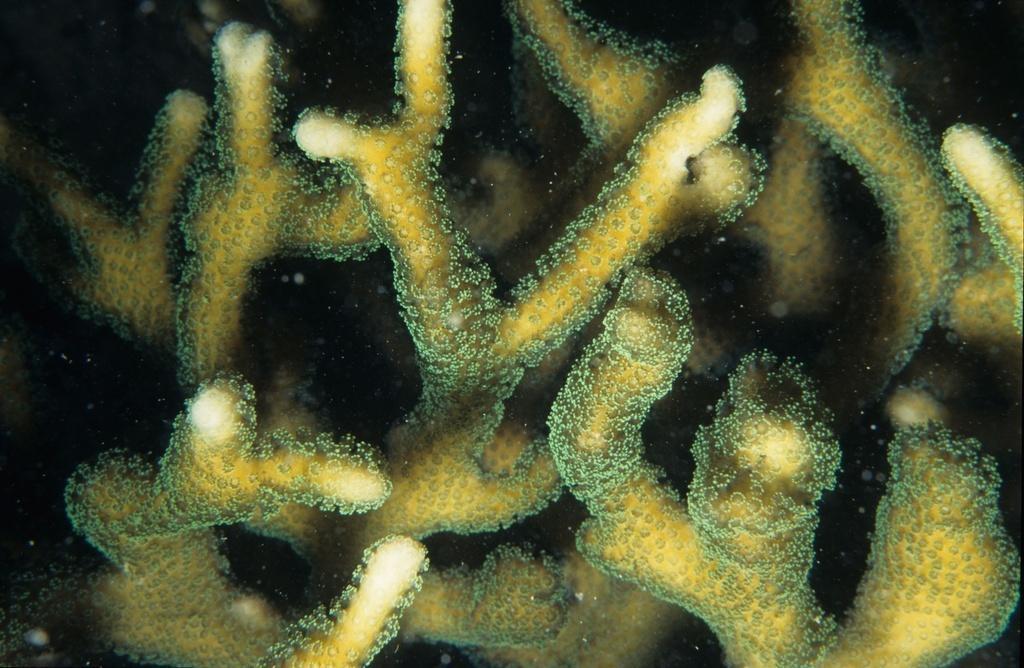In one or two sentences, can you explain what this image depicts? In this image we can see the coral reef. 